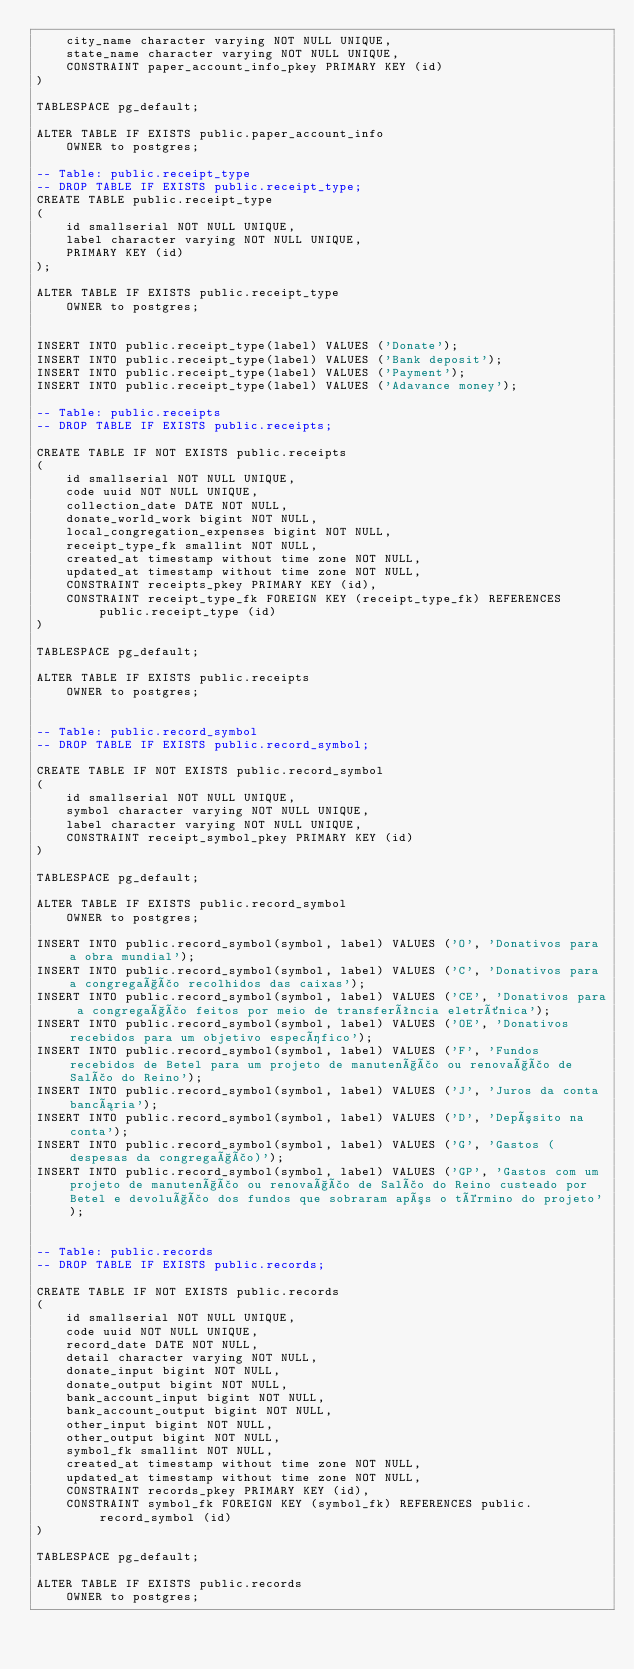Convert code to text. <code><loc_0><loc_0><loc_500><loc_500><_SQL_>    city_name character varying NOT NULL UNIQUE,
    state_name character varying NOT NULL UNIQUE,
    CONSTRAINT paper_account_info_pkey PRIMARY KEY (id)
)

TABLESPACE pg_default;

ALTER TABLE IF EXISTS public.paper_account_info
    OWNER to postgres;

-- Table: public.receipt_type
-- DROP TABLE IF EXISTS public.receipt_type;
CREATE TABLE public.receipt_type
(
    id smallserial NOT NULL UNIQUE,
    label character varying NOT NULL UNIQUE,
    PRIMARY KEY (id)
);

ALTER TABLE IF EXISTS public.receipt_type
    OWNER to postgres;


INSERT INTO public.receipt_type(label) VALUES ('Donate');
INSERT INTO public.receipt_type(label) VALUES ('Bank deposit');
INSERT INTO public.receipt_type(label) VALUES ('Payment');
INSERT INTO public.receipt_type(label) VALUES ('Adavance money');

-- Table: public.receipts
-- DROP TABLE IF EXISTS public.receipts;

CREATE TABLE IF NOT EXISTS public.receipts
(
    id smallserial NOT NULL UNIQUE,
    code uuid NOT NULL UNIQUE,
    collection_date DATE NOT NULL,
    donate_world_work bigint NOT NULL,
    local_congregation_expenses bigint NOT NULL,
    receipt_type_fk smallint NOT NULL,
    created_at timestamp without time zone NOT NULL,
    updated_at timestamp without time zone NOT NULL,
    CONSTRAINT receipts_pkey PRIMARY KEY (id),
    CONSTRAINT receipt_type_fk FOREIGN KEY (receipt_type_fk) REFERENCES public.receipt_type (id)
)

TABLESPACE pg_default;

ALTER TABLE IF EXISTS public.receipts
    OWNER to postgres;


-- Table: public.record_symbol
-- DROP TABLE IF EXISTS public.record_symbol;

CREATE TABLE IF NOT EXISTS public.record_symbol
(
    id smallserial NOT NULL UNIQUE,
    symbol character varying NOT NULL UNIQUE,
    label character varying NOT NULL UNIQUE,
    CONSTRAINT receipt_symbol_pkey PRIMARY KEY (id)
)

TABLESPACE pg_default;

ALTER TABLE IF EXISTS public.record_symbol
    OWNER to postgres;

INSERT INTO public.record_symbol(symbol, label)	VALUES ('O', 'Donativos para a obra mundial');
INSERT INTO public.record_symbol(symbol, label)	VALUES ('C', 'Donativos para a congregação recolhidos das caixas');
INSERT INTO public.record_symbol(symbol, label)	VALUES ('CE', 'Donativos para a congregação feitos por meio de transferência eletrônica');
INSERT INTO public.record_symbol(symbol, label)	VALUES ('OE', 'Donativos recebidos para um objetivo específico');
INSERT INTO public.record_symbol(symbol, label)	VALUES ('F', 'Fundos recebidos de Betel para um projeto de manutenção ou renovação de Salão do Reino');
INSERT INTO public.record_symbol(symbol, label)	VALUES ('J', 'Juros da conta bancária');
INSERT INTO public.record_symbol(symbol, label)	VALUES ('D', 'Depósito na conta');
INSERT INTO public.record_symbol(symbol, label)	VALUES ('G', 'Gastos (despesas da congregação)');
INSERT INTO public.record_symbol(symbol, label)	VALUES ('GP', 'Gastos com um projeto de manutenção ou renovação de Salão do Reino custeado por Betel e devolução dos fundos que sobraram após o término do projeto');


-- Table: public.records
-- DROP TABLE IF EXISTS public.records;

CREATE TABLE IF NOT EXISTS public.records
(
    id smallserial NOT NULL UNIQUE,
    code uuid NOT NULL UNIQUE,
    record_date DATE NOT NULL,
    detail character varying NOT NULL,
    donate_input bigint NOT NULL,
    donate_output bigint NOT NULL,
    bank_account_input bigint NOT NULL,
    bank_account_output bigint NOT NULL,
    other_input bigint NOT NULL,
    other_output bigint NOT NULL,
    symbol_fk smallint NOT NULL,
    created_at timestamp without time zone NOT NULL,
    updated_at timestamp without time zone NOT NULL,
    CONSTRAINT records_pkey PRIMARY KEY (id),
    CONSTRAINT symbol_fk FOREIGN KEY (symbol_fk) REFERENCES public.record_symbol (id)
)

TABLESPACE pg_default;

ALTER TABLE IF EXISTS public.records
    OWNER to postgres;</code> 